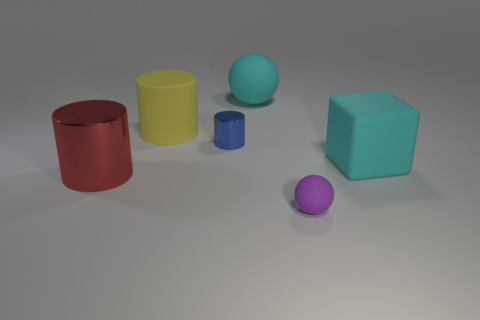There is another large object that is the same shape as the purple matte thing; what material is it?
Your answer should be very brief. Rubber. How many cyan things have the same shape as the tiny purple rubber object?
Offer a terse response. 1. What is the size of the cylinder in front of the cyan object that is to the right of the cyan ball?
Provide a short and direct response. Large. There is a yellow cylinder that is the same size as the block; what is its material?
Ensure brevity in your answer.  Rubber. Are there any big cyan things made of the same material as the large yellow thing?
Offer a very short reply. Yes. There is a tiny object that is right of the cyan rubber object that is to the left of the cyan object in front of the big matte ball; what is its color?
Provide a short and direct response. Purple. There is a metal cylinder that is in front of the cyan block; is it the same color as the big rubber cylinder that is behind the big shiny cylinder?
Your answer should be very brief. No. Is there anything else that is the same color as the small shiny object?
Give a very brief answer. No. Is the number of big rubber things that are to the right of the tiny sphere less than the number of objects?
Provide a short and direct response. Yes. What number of big brown rubber balls are there?
Ensure brevity in your answer.  0. 